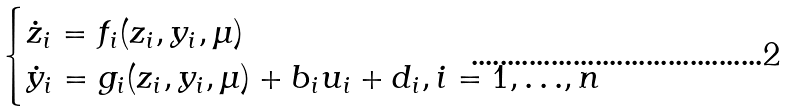<formula> <loc_0><loc_0><loc_500><loc_500>\begin{cases} \dot { z } _ { i } = f _ { i } ( z _ { i } , y _ { i } , \mu ) \\ \dot { y } _ { i } = g _ { i } ( z _ { i } , y _ { i } , \mu ) + b _ { i } u _ { i } + d _ { i } , i = 1 , { \dots } , n \end{cases}</formula> 